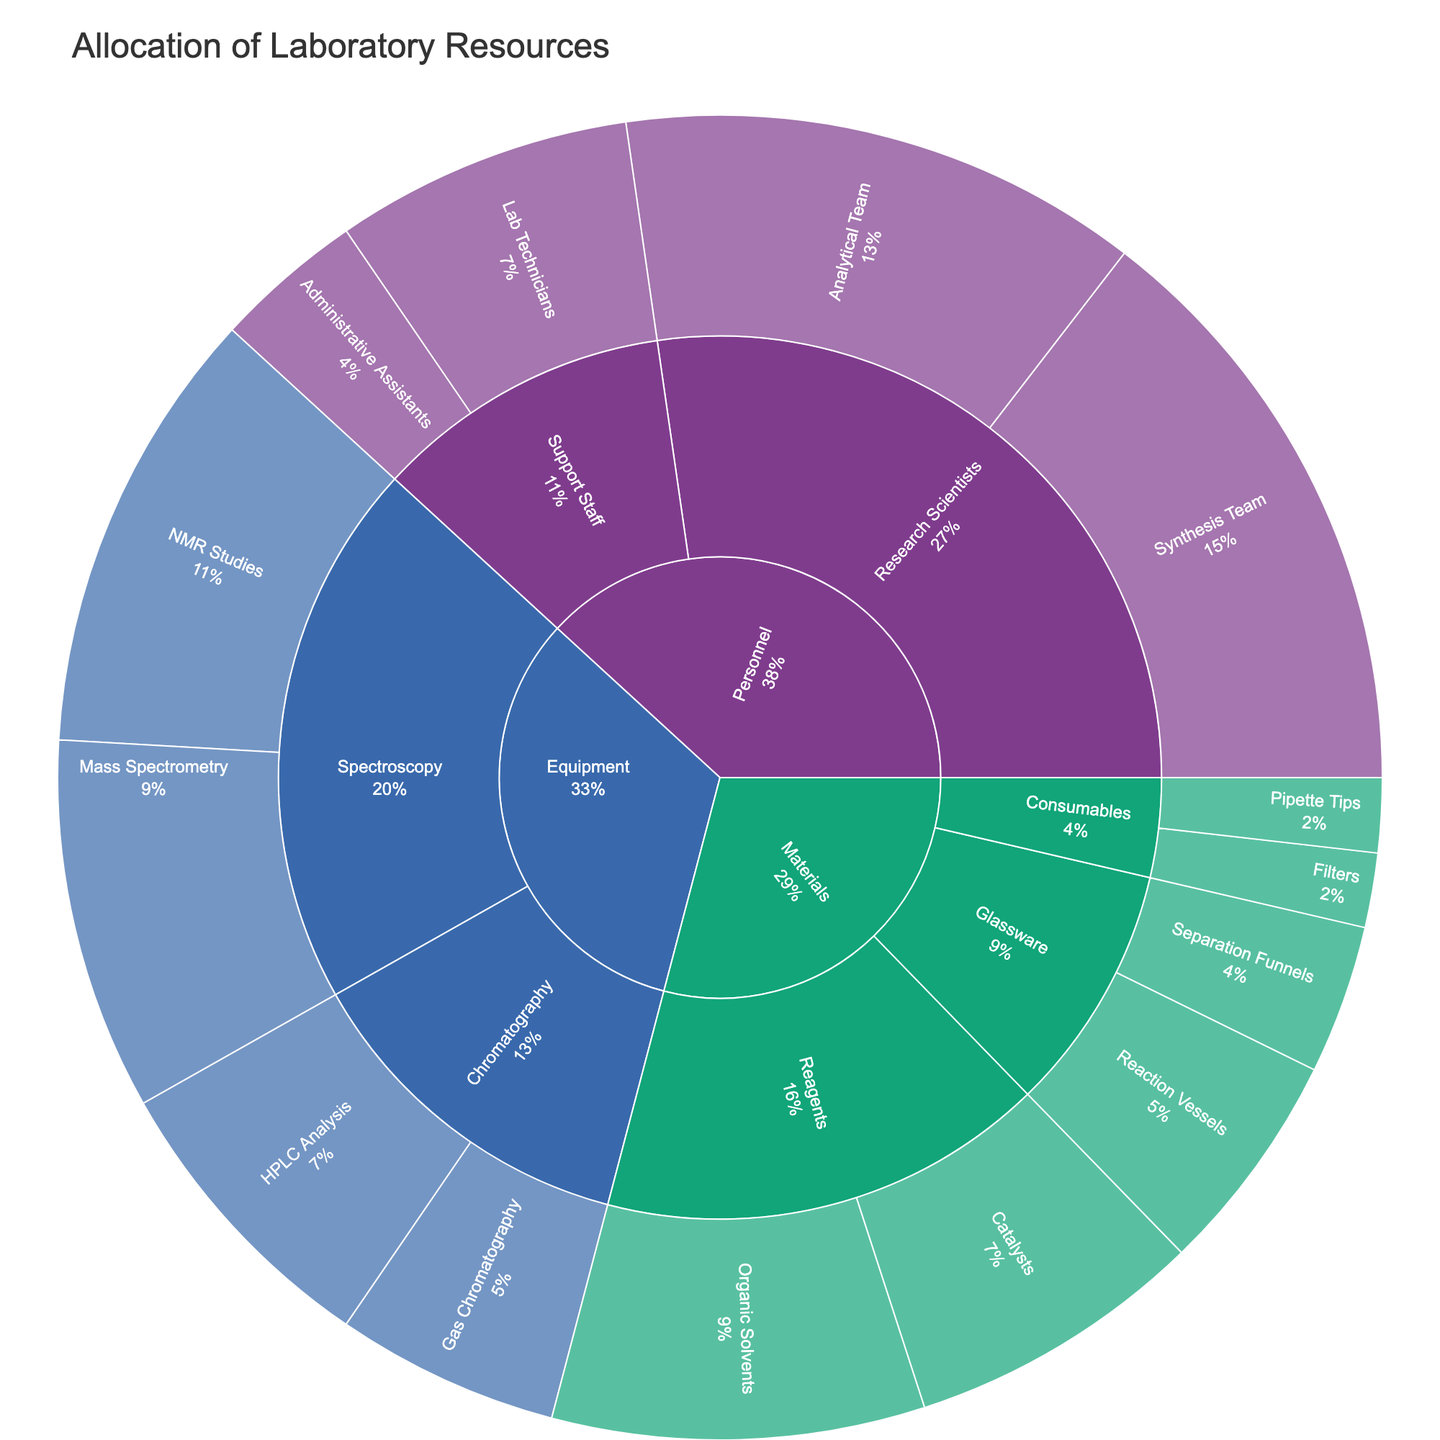What is the title of the Sunburst Plot? The title is usually found at the top of the figure. The figure provided is titled 'Allocation of Laboratory Resources'.
Answer: Allocation of Laboratory Resources Which category has the highest allocation of resources? By examining the plot, we see that the 'Personnel' category has the largest segment compared to 'Equipment' and 'Materials'. This observation is based on the visual size of the segments.
Answer: Personnel What is the total allocation for the 'Chromatography' subcategory? 'Chromatography' includes 'HPLC Analysis' (20) and 'Gas Chromatography' (15). Adding these values together yields 35.
Answer: 35 Which subcategory within 'Materials' has the least allocation? The smallest segment under 'Materials' is 'Consumables', which includes 'Pipette Tips' (5) and 'Filters' (5). These values are both smaller than any other subcategory under 'Materials'.
Answer: Consumables How does the allocation for 'Research Scientists' compare to the 'Support Staff'? 'Research Scientists' has segments for 'Synthesis Team' (40) and 'Analytical Team' (35), totaling 75, whereas 'Support Staff' includes 'Lab Technicians' (20) and 'Administrative Assistants' (10), totaling 30. Thus, the allocation for 'Research Scientists' is significantly higher.
Answer: 'Research Scientists' is higher What percentage of the total resources is allocated to 'NMR Studies'? The segment for 'NMR Studies' under 'Spectroscopy' within 'Equipment' has a value of 30. To find the percentage, we need to sum all the values (260) and then divide 30 by this total, which gives about 11.5%.
Answer: 11.5% Within the 'Materials' category, what is the combined allocation for 'Reagents'? 'Reagents' includes 'Organic Solvents' (25) and 'Catalysts' (20). Adding these together gives 45.
Answer: 45 Which project under 'Personnel' has the highest allocation? Within 'Personnel', the 'Synthesis Team' has the highest individual allocation of 40.
Answer: Synthesis Team What is the difference in allocation between 'HPLC Analysis' and 'Organic Solvents'? 'HPLC Analysis' has a value of 20, and 'Organic Solvents' has a value of 25. The difference between these allocations is 5.
Answer: 5 What fraction of the 'Equipment' category is dedicated to 'Gas Chromatography'? The 'Gas Chromatography' segment has a value of 15. The total value of the 'Equipment' category is the sum of all its subcategories: 30 (NMR Studies) + 25 (Mass Spectrometry) + 20 (HPLC Analysis) + 15 (Gas Chromatography) = 90. The fraction is 15/90, which simplifies to 1/6.
Answer: 1/6 